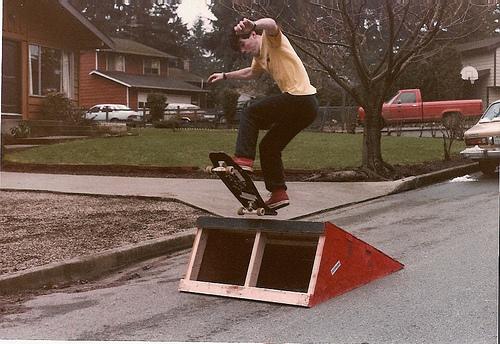How many skateboards are there?
Keep it brief. 1. What shoes does the man have on?
Write a very short answer. Sneakers. Is this at a skate park?
Keep it brief. No. 